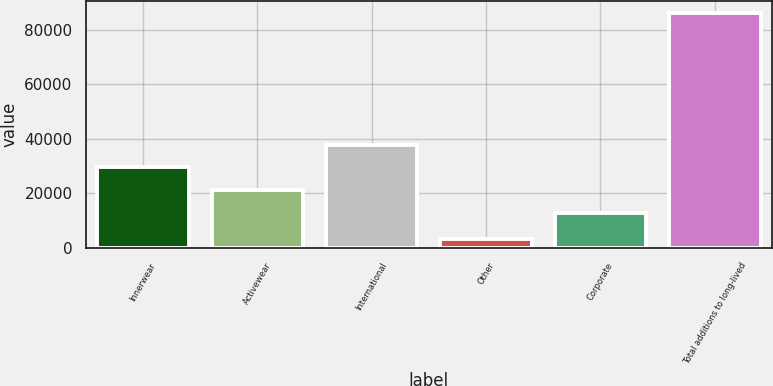Convert chart. <chart><loc_0><loc_0><loc_500><loc_500><bar_chart><fcel>Innerwear<fcel>Activewear<fcel>International<fcel>Other<fcel>Corporate<fcel>Total additions to long-lived<nl><fcel>29571.4<fcel>21264.2<fcel>37878.6<fcel>3221<fcel>12957<fcel>86293<nl></chart> 